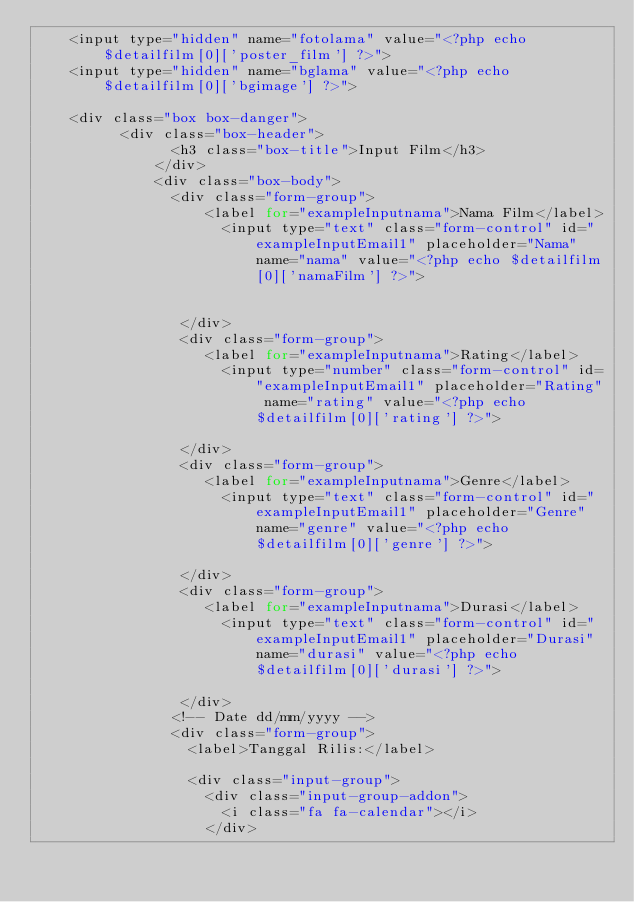<code> <loc_0><loc_0><loc_500><loc_500><_PHP_> 		<input type="hidden" name="fotolama" value="<?php echo $detailfilm[0]['poster_film'] ?>">
 		<input type="hidden" name="bglama" value="<?php echo $detailfilm[0]['bgimage'] ?>">

 		<div class="box box-danger">
	        <div class="box-header">
	              <h3 class="box-title">Input Film</h3>
	            </div>
	            <div class="box-body">
	            	<div class="form-group">
		                <label for="exampleInputnama">Nama Film</label>
	                  	<input type="text" class="form-control" id="exampleInputEmail1" placeholder="Nama" name="nama" value="<?php echo $detailfilm[0]['namaFilm'] ?>">
		               
		           		
	             	 </div>
	             	 <div class="form-group">
		                <label for="exampleInputnama">Rating</label>
	                  	<input type="number" class="form-control" id="exampleInputEmail1" placeholder="Rating" name="rating" value="<?php echo $detailfilm[0]['rating'] ?>">		               	
	             	 </div>
	             	 <div class="form-group">
		                <label for="exampleInputnama">Genre</label>
	                  	<input type="text" class="form-control" id="exampleInputEmail1" placeholder="Genre" name="genre" value="<?php echo $detailfilm[0]['genre'] ?>">	           		
	             	 </div>
	             	 <div class="form-group">
		                <label for="exampleInputnama">Durasi</label>
	                  	<input type="text" class="form-control" id="exampleInputEmail1" placeholder="Durasi" name="durasi" value="<?php echo $detailfilm[0]['durasi'] ?>">	           		
	             	 </div>
	              <!-- Date dd/mm/yyyy -->
	              <div class="form-group">
	                <label>Tanggal Rilis:</label>

	                <div class="input-group">
	                  <div class="input-group-addon">
	                    <i class="fa fa-calendar"></i>
	                  </div></code> 